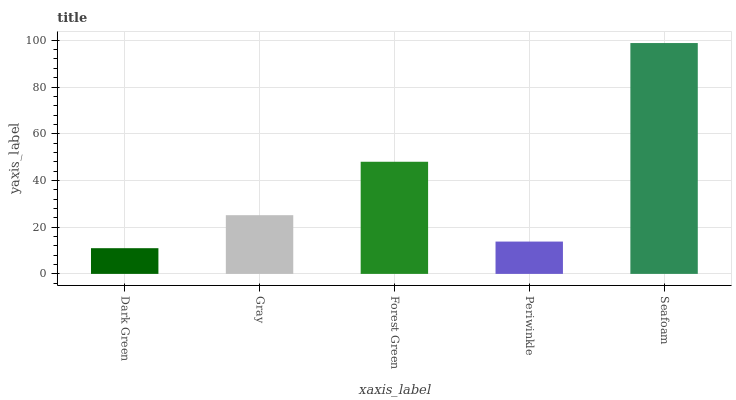Is Dark Green the minimum?
Answer yes or no. Yes. Is Seafoam the maximum?
Answer yes or no. Yes. Is Gray the minimum?
Answer yes or no. No. Is Gray the maximum?
Answer yes or no. No. Is Gray greater than Dark Green?
Answer yes or no. Yes. Is Dark Green less than Gray?
Answer yes or no. Yes. Is Dark Green greater than Gray?
Answer yes or no. No. Is Gray less than Dark Green?
Answer yes or no. No. Is Gray the high median?
Answer yes or no. Yes. Is Gray the low median?
Answer yes or no. Yes. Is Periwinkle the high median?
Answer yes or no. No. Is Dark Green the low median?
Answer yes or no. No. 